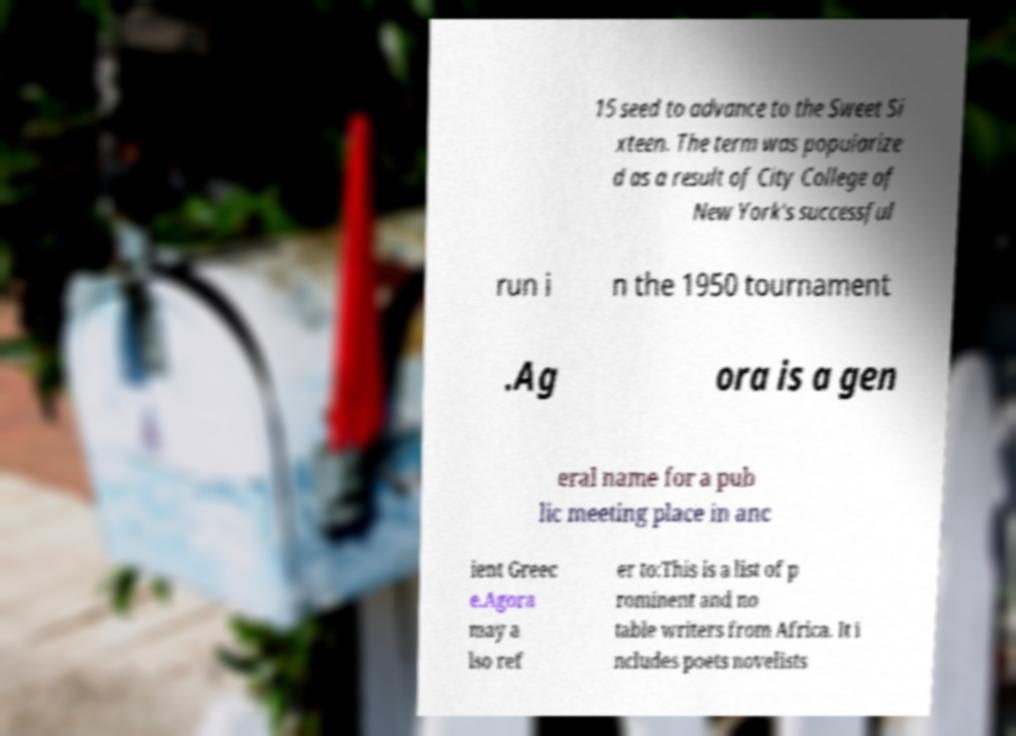Could you extract and type out the text from this image? 15 seed to advance to the Sweet Si xteen. The term was popularize d as a result of City College of New York's successful run i n the 1950 tournament .Ag ora is a gen eral name for a pub lic meeting place in anc ient Greec e.Agora may a lso ref er to:This is a list of p rominent and no table writers from Africa. It i ncludes poets novelists 